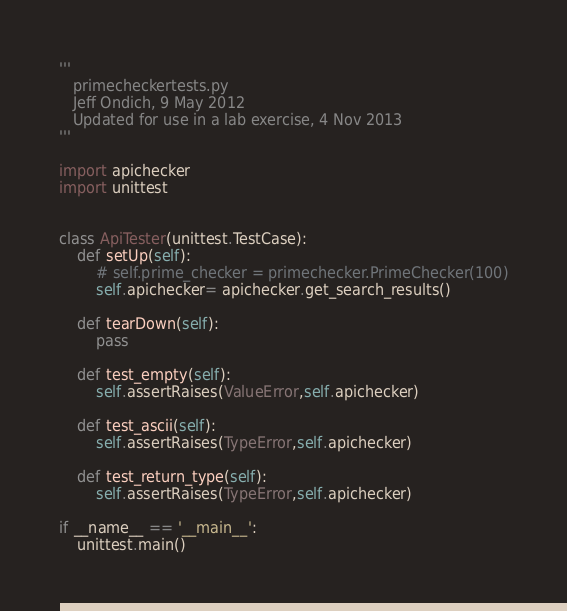<code> <loc_0><loc_0><loc_500><loc_500><_Python_>'''
   primecheckertests.py
   Jeff Ondich, 9 May 2012
   Updated for use in a lab exercise, 4 Nov 2013
'''

import apichecker
import unittest


class ApiTester(unittest.TestCase):
    def setUp(self):
        # self.prime_checker = primechecker.PrimeChecker(100)
        self.apichecker= apichecker.get_search_results()

    def tearDown(self):
        pass

    def test_empty(self):
        self.assertRaises(ValueError,self.apichecker)

    def test_ascii(self):
        self.assertRaises(TypeError,self.apichecker)

    def test_return_type(self):
        self.assertRaises(TypeError,self.apichecker)

if __name__ == '__main__':
    unittest.main()
</code> 